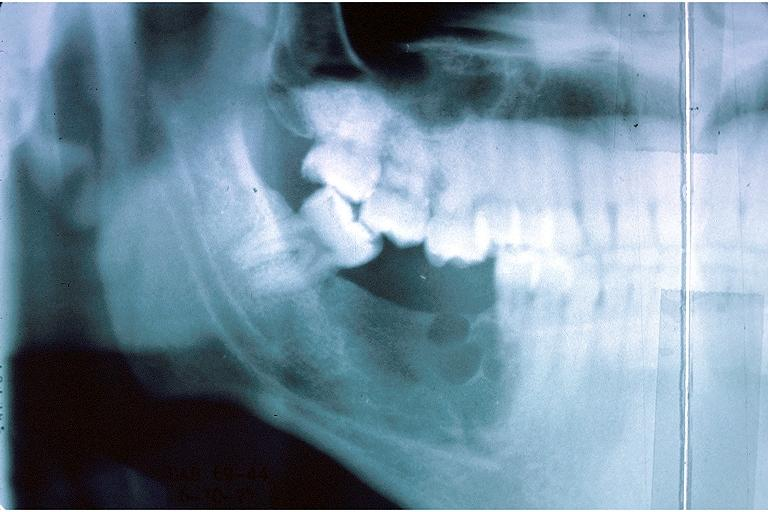where is this?
Answer the question using a single word or phrase. Oral 